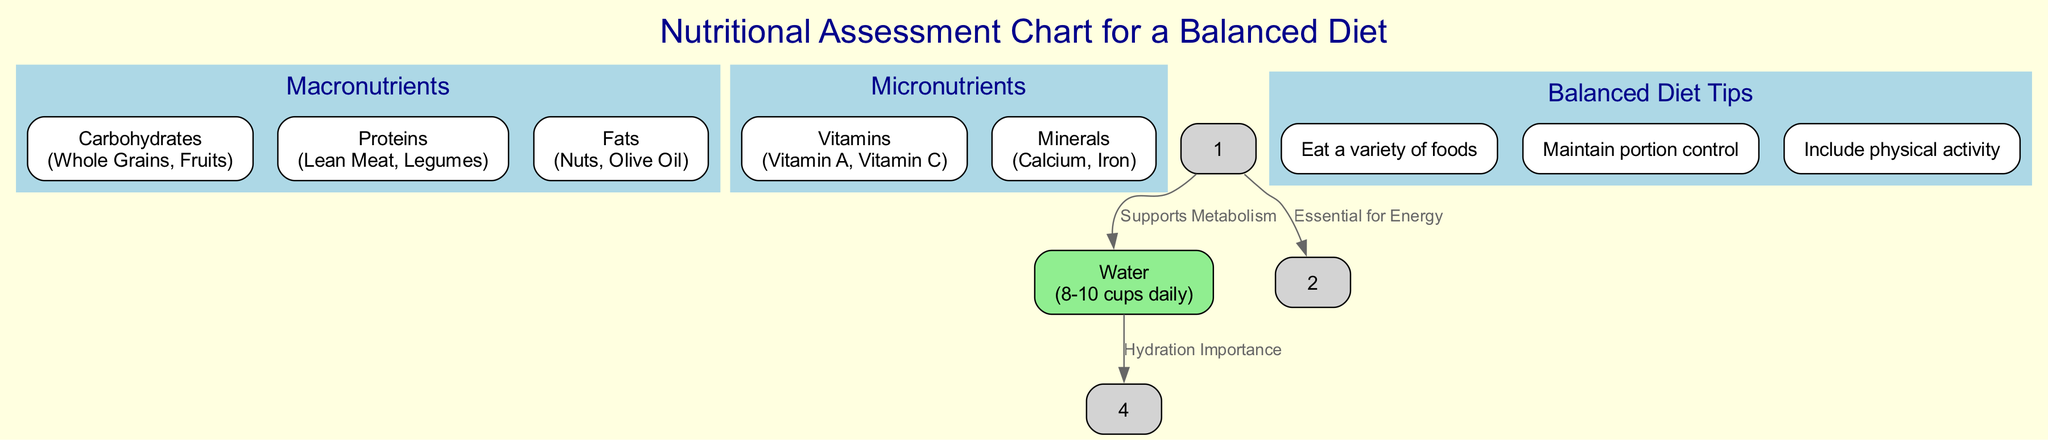What is the main category of nutrients represented at the top of the diagram? The diagram starts with the node labeled "Macronutrients," which is positioned at the top of the structure, indicating that it is the main category of nutrients discussed.
Answer: Macronutrients How many types of macronutrients are listed in the diagram? The node for "Macronutrients" contains three elements: Carbohydrates, Proteins, and Fats. By counting these, we see that there are three types of macronutrients mentioned.
Answer: 3 What are the two types of micronutrients identified in the chart? The node for "Micronutrients" includes two elements: Vitamins and Minerals. These are specifically named within the node, giving a direct answer to the question.
Answer: Vitamins, Minerals What is the recommended daily water intake shown in the diagram? The "Water" node contains the example "8-10 cups daily," which specifies the recommended daily water intake for an individual.
Answer: 8-10 cups daily What is one of the tips provided in the "Balanced Diet Tips" section? Looking at the "Balanced Diet Tips" node, one of the listed elements is "Eat a variety of foods," which is a suggested practice for maintaining a balanced diet according to the diagram.
Answer: Eat a variety of foods What relationship is described between macronutrients and micronutrients? The edge connecting "Macronutrients" to "Micronutrients" is labeled "Essential for Energy," indicating that macronutrients play a crucial role in providing energy which is essential for the functions of micronutrients.
Answer: Essential for Energy How many edges are present in the diagram? The edges drawn in the diagram connect various nodes, and by counting these, we find that there are three edges total in the structure connecting different components.
Answer: 3 Why is water mentioned in connection to balanced diet tips? The edge from the "Water" node to the "Balanced Diet Tips" node, labeled "Hydration Importance," illustrates the connection that emphasizes the significance of hydration in maintaining a balanced diet.
Answer: Hydration Importance Which micronutrient examples are listed under the Micronutrients node? Within the "Micronutrients" node, two examples are explicitly provided: Vitamin A and Vitamin C, which represent different types of vitamins mentioned in the diagram.
Answer: Vitamin A, Vitamin C 